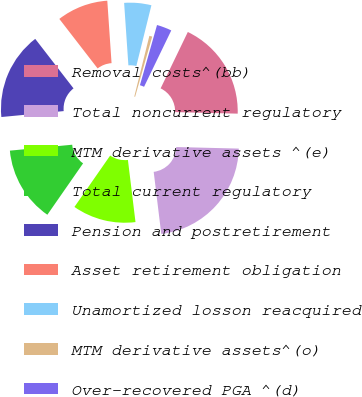Convert chart. <chart><loc_0><loc_0><loc_500><loc_500><pie_chart><fcel>Removal costs^(bb)<fcel>Total noncurrent regulatory<fcel>MTM derivative assets ^(e)<fcel>Total current regulatory<fcel>Pension and postretirement<fcel>Asset retirement obligation<fcel>Unamortized losson reacquired<fcel>MTM derivative assets^(o)<fcel>Over-recovered PGA ^(d)<nl><fcel>18.24%<fcel>22.67%<fcel>11.6%<fcel>13.82%<fcel>16.03%<fcel>9.39%<fcel>4.96%<fcel>0.53%<fcel>2.75%<nl></chart> 